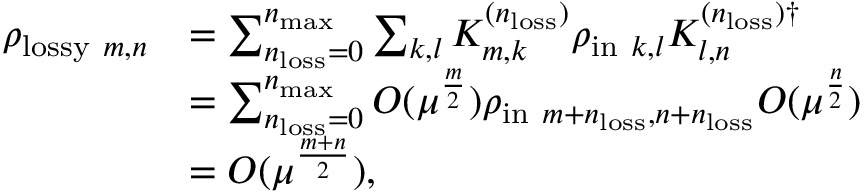Convert formula to latex. <formula><loc_0><loc_0><loc_500><loc_500>\begin{array} { r l } { \rho _ { l o s s y m , n } } & { = \sum _ { n _ { l o s s } = 0 } ^ { n _ { \max } } \sum _ { k , l } K _ { m , k } ^ { ( n _ { l o s s } ) } \rho _ { i n k , l } K _ { l , n } ^ { ( n _ { l o s s } ) \dag } } \\ & { = \sum _ { n _ { l o s s } = 0 } ^ { n _ { \max } } O ( \mu ^ { \frac { m } { 2 } } ) \rho _ { i n m + n _ { l o s s } , n + n _ { l o s s } } O ( \mu ^ { \frac { n } { 2 } } ) } \\ & { = O ( \mu ^ { \frac { m + n } { 2 } } ) , } \end{array}</formula> 